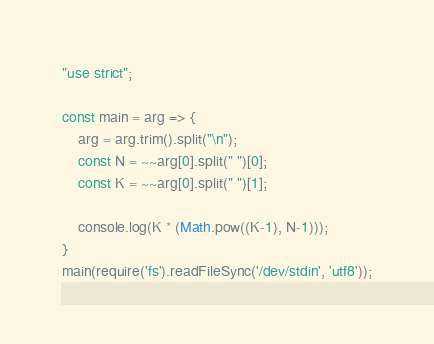Convert code to text. <code><loc_0><loc_0><loc_500><loc_500><_JavaScript_>"use strict";
    
const main = arg => {
    arg = arg.trim().split("\n");
    const N = ~~arg[0].split(" ")[0];
    const K = ~~arg[0].split(" ")[1];
    
    console.log(K * (Math.pow((K-1), N-1)));
}
main(require('fs').readFileSync('/dev/stdin', 'utf8'));</code> 